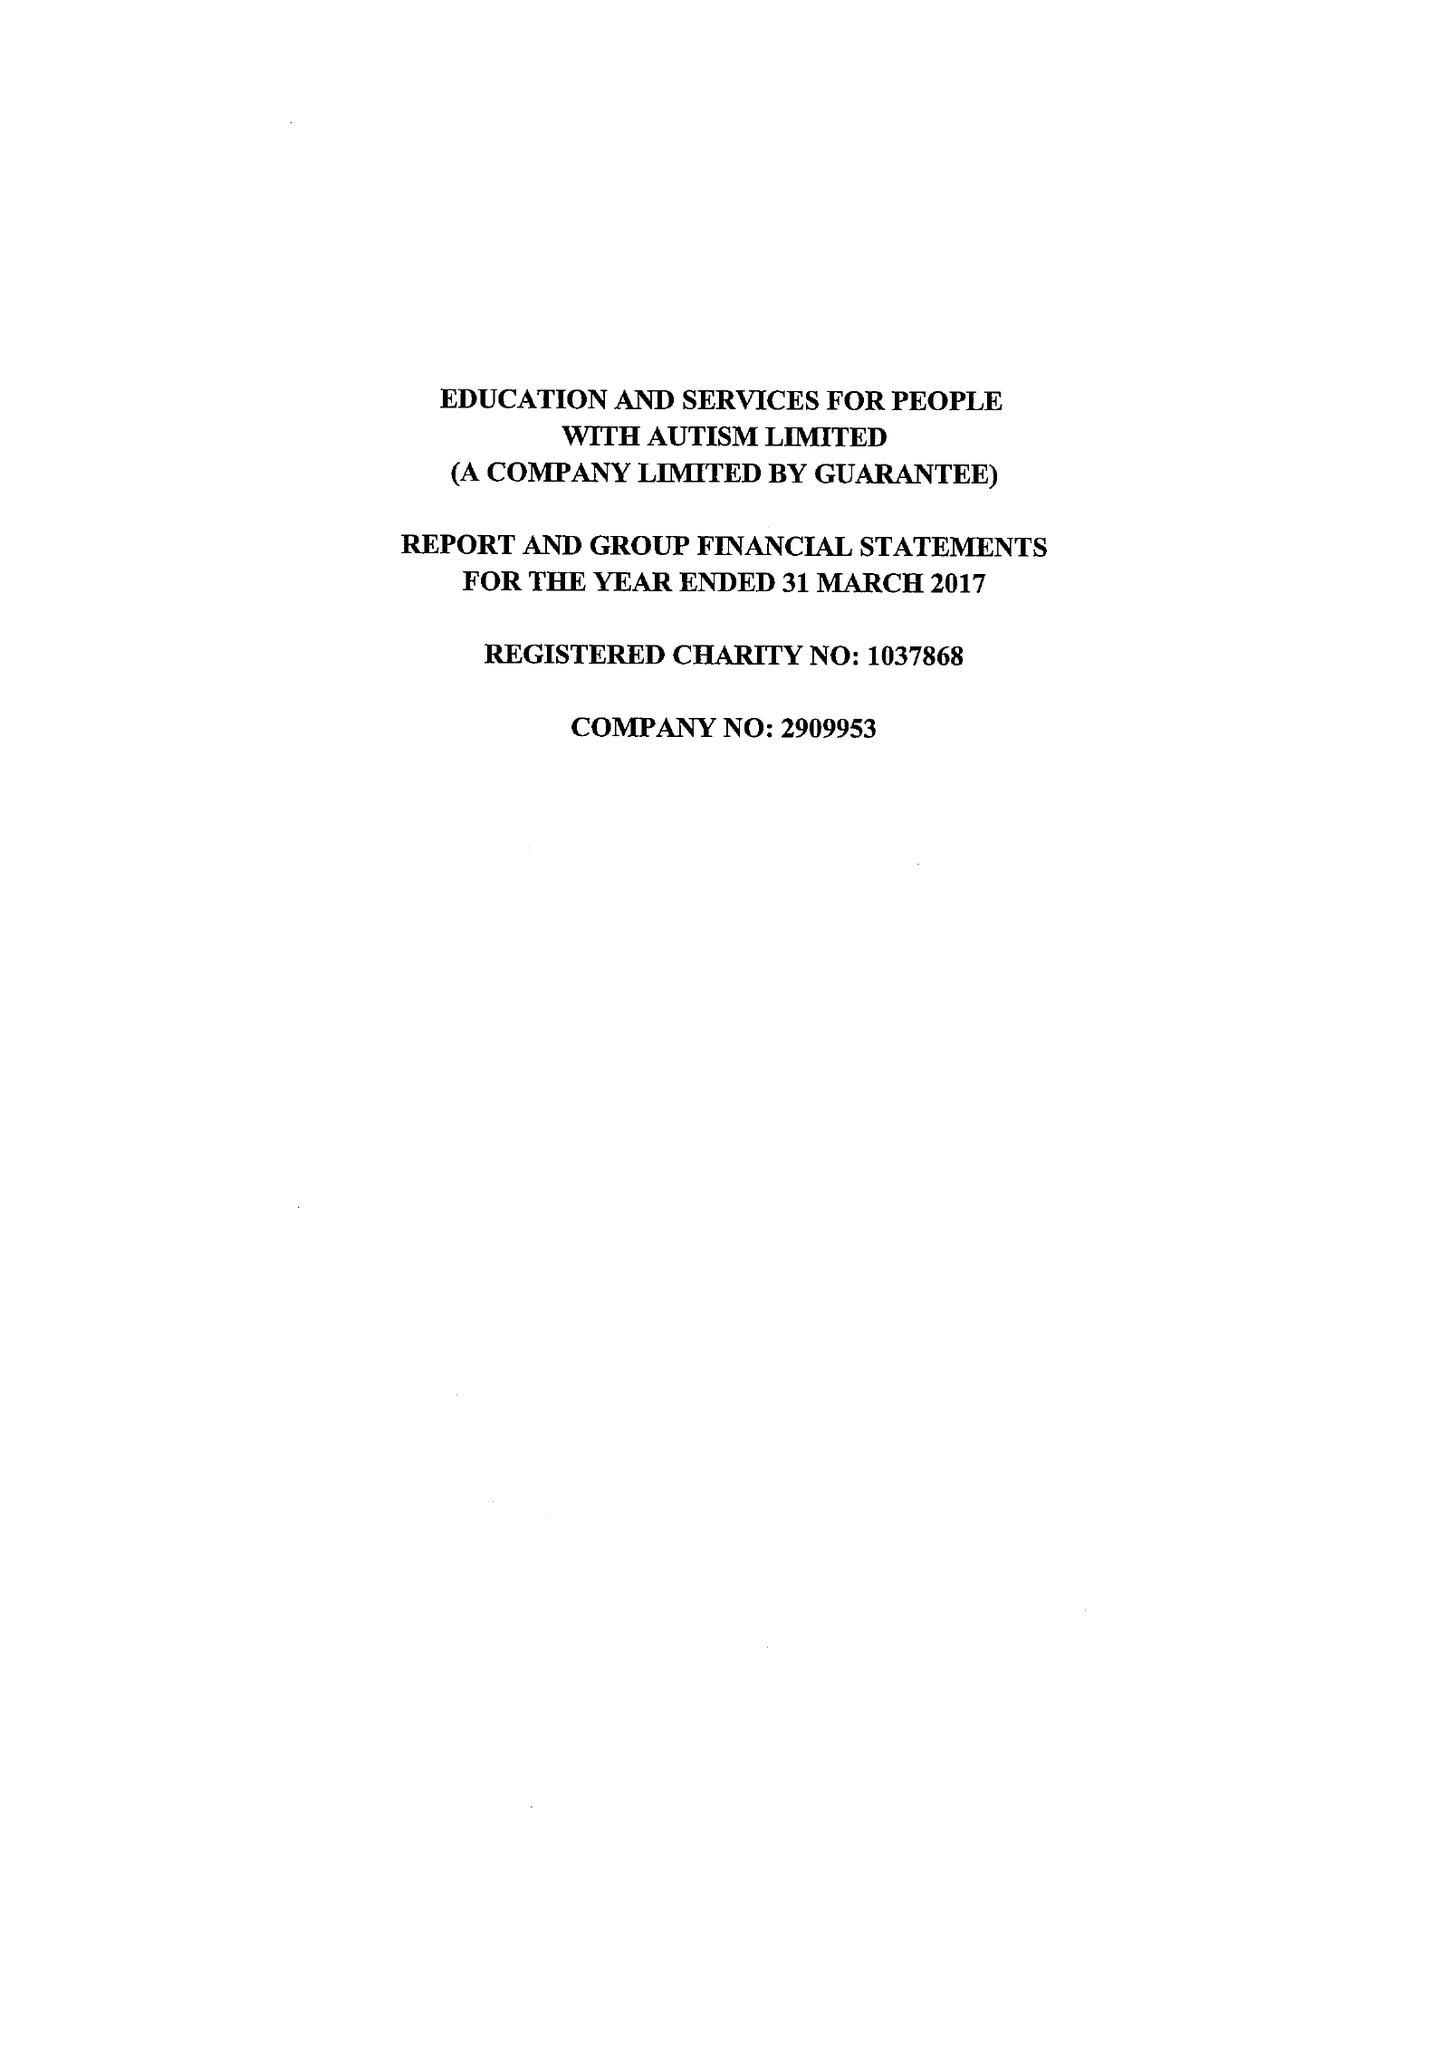What is the value for the address__street_line?
Answer the question using a single word or phrase. HYLTON PARK ROAD 